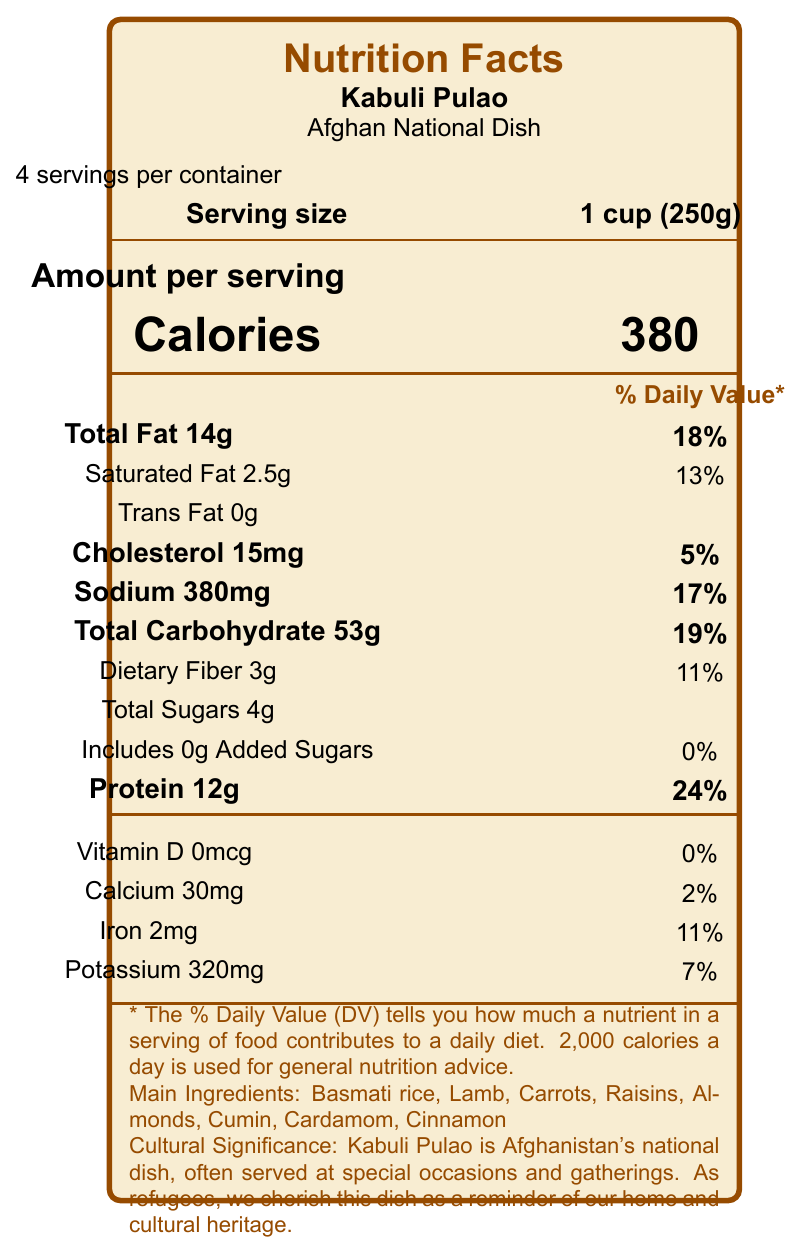what is the serving size? The serving size is mentioned under the section "Serving size" next to the label stating "1 cup (250g)."
Answer: 1 cup (250g) what is the total fat content per serving? The total fat content per serving is listed as "Total Fat 14g" under the "Amount per serving" section.
Answer: 14g how much protein does one serving provide? The protein content per serving is specified as "Protein 12g" in the "Amount per serving" section.
Answer: 12g what is the cultural significance of Kabuli Pulao? The cultural significance is detailed at the bottom of the document, stating "Kabuli Pulao is Afghanistan's national dish, often served at special occasions and gatherings."
Answer: Kabuli Pulao is Afghanistan's national dish, often served at special occasions and gatherings. how many servings are in one container? The number of servings per container is indicated at the top left section of the document as "4 servings per container."
Answer: 4 what is the calorie count per serving? The number of calories per serving is listed prominently in the "Amount per serving" section as "Calories 380."
Answer: 380 how much sodium is in one serving? The sodium content per serving is stated in the "Amount per serving" section as "Sodium 380mg."
Answer: 380mg what are the main ingredients in Kabuli Pulao? The main ingredients are listed at the bottom of the document as "Basmati rice, Lamb, Carrots, Raisins, Almonds, Cumin, Cardamom, Cinnamon."
Answer: Basmati rice, Lamb, Carrots, Raisins, Almonds, Cumin, Cardamom, Cinnamon how much iron does one serving contain? The iron content per serving is listed in the "Amount per serving" section as "Iron 2mg" with a daily value of 11%.
Answer: 2mg how much dietary fiber is in a single serving? The dietary fiber content per serving is mentioned under "Total Carbohydrate" as "Dietary Fiber 3g."
Answer: 3g the document mentions a vegetarian adaptation for school meals. What ingredient replaces lamb? A. Chicken B. Tofu C. Chickpeas D. Beans The adaptation is to use "chickpeas" instead of lamb, mentioned towards the end of the document under adaptations.
Answer: C which nutrient in Kabuli Pulao has the highest percent daily value per serving? 1. Total Fat 2. Protein 3. Sodium 4. Total Carbohydrate Protein has the highest percent daily value of 24%, which is higher than Total Fat (18%), Sodium (17%), and Total Carbohydrate (19%).
Answer: 2 is there any trans fat in Kabuli Pulao? The document specifies "Trans Fat 0g," indicating there is no trans fat in Kabuli Pulao.
Answer: No does Kabuli Pulao contain any added sugars? The document states "Includes 0g Added Sugars," meaning there are no added sugars in Kabuli Pulao.
Answer: No summarize the nutritional content and cultural significance of Kabuli Pulao as detailed in the document. The document details the nutritional content of Kabuli Pulao, breaking down its calorie, fat, protein, and carbohydrate content per serving, along with its cultural significance as Afghanistan's national dish and its educational value for teaching about nutrition and cultural diversity. It also discusses potential vegetarian adaptations for school meals.
Answer: Kabuli Pulao is a traditional Afghan dish with 380 calories per serving and contains main ingredients like Basmati rice, lamb, carrots, raisins, almonds, cumin, cardamom, and cinnamon. Notable nutritional contents include 14g of total fat, 12g of protein, and 53g of carbohydrates per serving. It holds cultural significance as Afghanistan's national dish, often served at special gatherings, and is cherished by Afghan refugees as a reminder of their home. Additionally, it can be used educationally to teach about balanced meals and cultural diversity. how much vitamin C is there in one serving of Kabuli Pulao? The document does not provide information on vitamin C content, so it cannot be determined.
Answer: Not enough information 